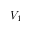<formula> <loc_0><loc_0><loc_500><loc_500>V _ { 1 }</formula> 